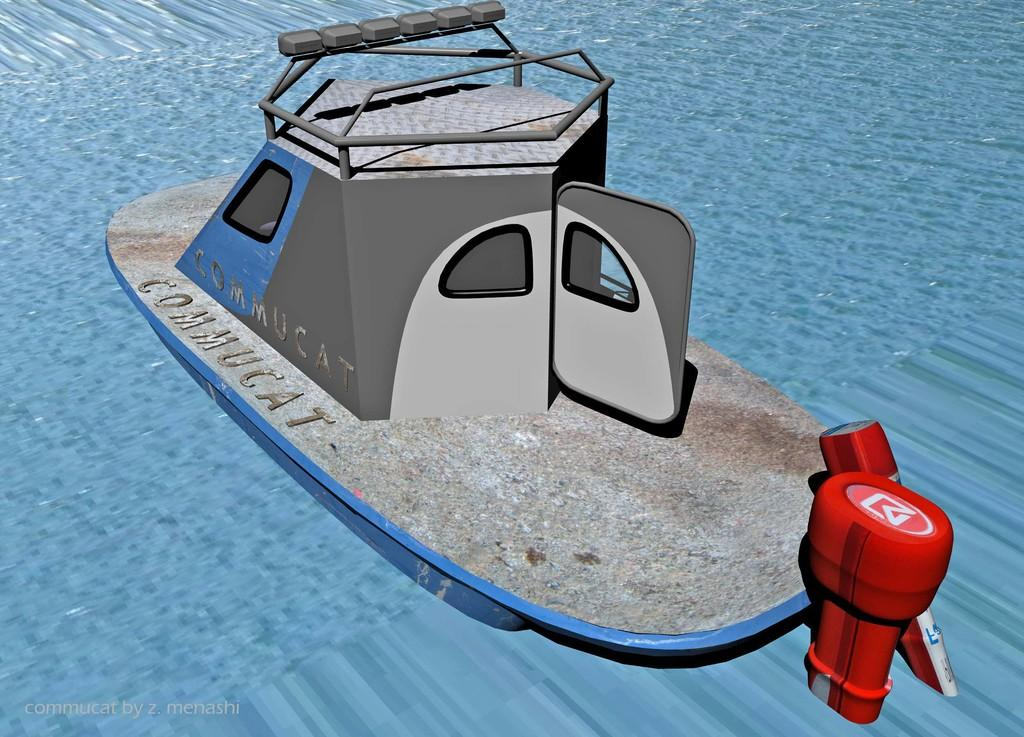What type of picture is the image? The image is an animated picture. What can be seen in the water in the image? There is a boat in the image. What is the purpose of the watermark in the image? The watermark is in the left corner of the image. What features does the boat have? The boat has windows, a door, and a red-colored motor. What type of bushes can be seen surrounding the boat in the image? There are no bushes present in the image; it features a boat in the water with a watermark in the left corner. What kind of mask is the boat wearing in the image? There is no mask present in the image; it features a boat with windows, a door, and a red-colored motor. 